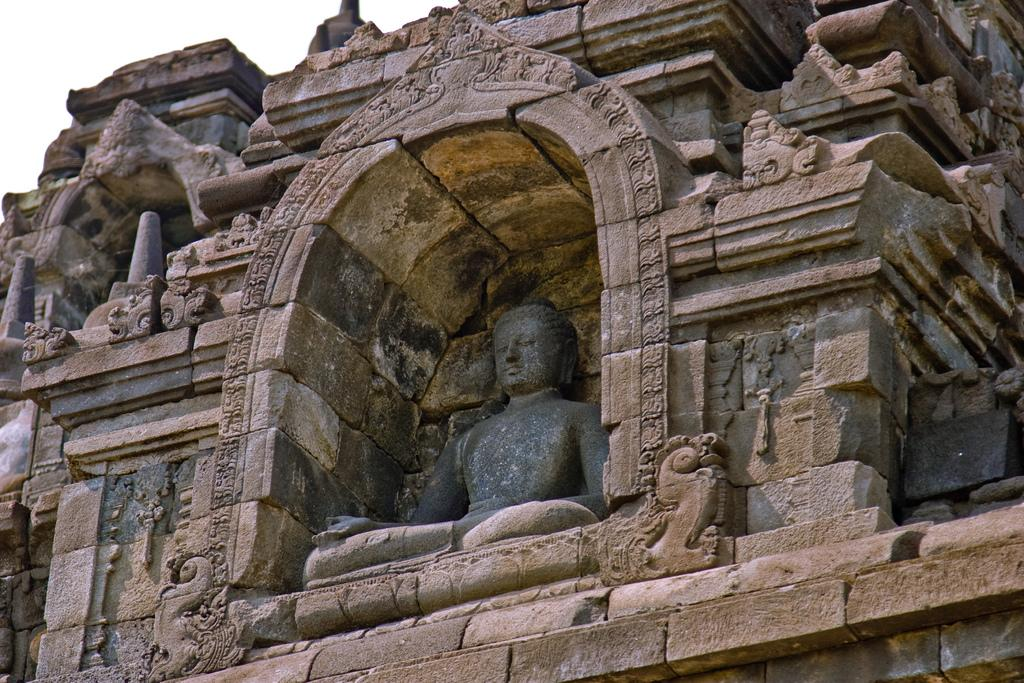What type of structure is in the image? There is a building in the image. Where is the building located in the image? The building is in the center of the image. What else can be seen in the center of the image? There is a statue of Buddha in the center of the image. What type of engine can be seen powering the statue of Buddha in the image? There is no engine present in the image, and the statue of Buddha is not powered by any engine. 